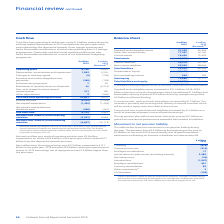According to Unilever Plc's financial document, What caused the increase in Goodwill in 2019? mainly as a result of acquisitions which contributed €1.2 billion and favourable currency impact of €0.5 billion driven by strengthening of the US Dollar and Pound Sterling.. The document states: "s increased to €31.0 billion (2018: €29.5 billion) mainly as a result of acquisitions which contributed €1.2 billion and favourable currency impact of..." Also, What caused the increase in the cash and cash equivalents in 2019? The increase is primarily due to strong cash delivery in several countries which will be used to repay short term debt in due course.. The document states: "sh and cash equivalents increased by €1.0 billion. The increase is primarily due to strong cash delivery in several countries which will be used to re..." Also, What caused the increase in the Current and non-current financial liabilities in 2019? as a result of commercial paper issue and bank borrowings.. The document states: "nt financial liabilities increased by €1.5 billion as a result of commercial paper issue and bank borrowings...." Also, can you calculate: What is the increase in Goodwill and intangible assets from 2018 to 2019? Based on the calculation: 31,029 - 29,493, the result is 1536 (in millions). This is based on the information: "Goodwill and intangible assets 31,029 29,493 Goodwill and intangible assets 31,029 29,493..." The key data points involved are: 29,493, 31,029. Also, can you calculate: What is the percentage increase / (decrease) in Total Assets from 2018? To answer this question, I need to perform calculations using the financial data. The calculation is: 64,806 / 61,111 - 1, which equals 6.05 (percentage). This is based on the information: "Total assets 64,806 61,111 Total assets 64,806 61,111..." The key data points involved are: 61,111, 64,806. Also, can you calculate: What is the Current Ratio in 2019? Based on the calculation: 16,430 / 20,978, the result is 0.78. This is based on the information: "Current liabilities 20,978 20,150 Current assets 16,430 15,478..." The key data points involved are: 16,430, 20,978. 